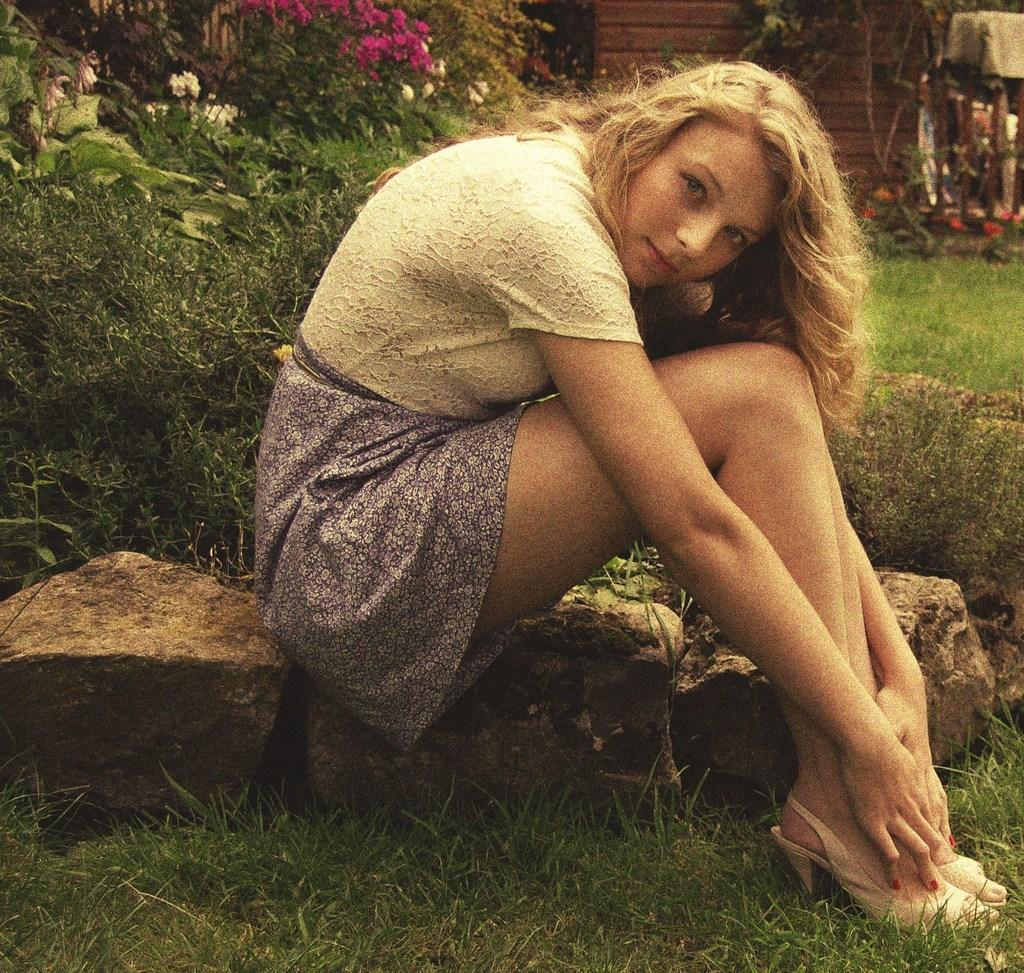What is the woman in the image doing? The woman is sitting in the image. What can be seen in the background of the image? There are plants and different types of flowers in the background of the image. What type of vegetation is visible in the front and back of the image? Grass is visible in the front and back of the image. What type of can is visible in the image? There is no can present in the image. What type of vessel is the woman holding in the image? The woman is not holding any vessel in the image. 